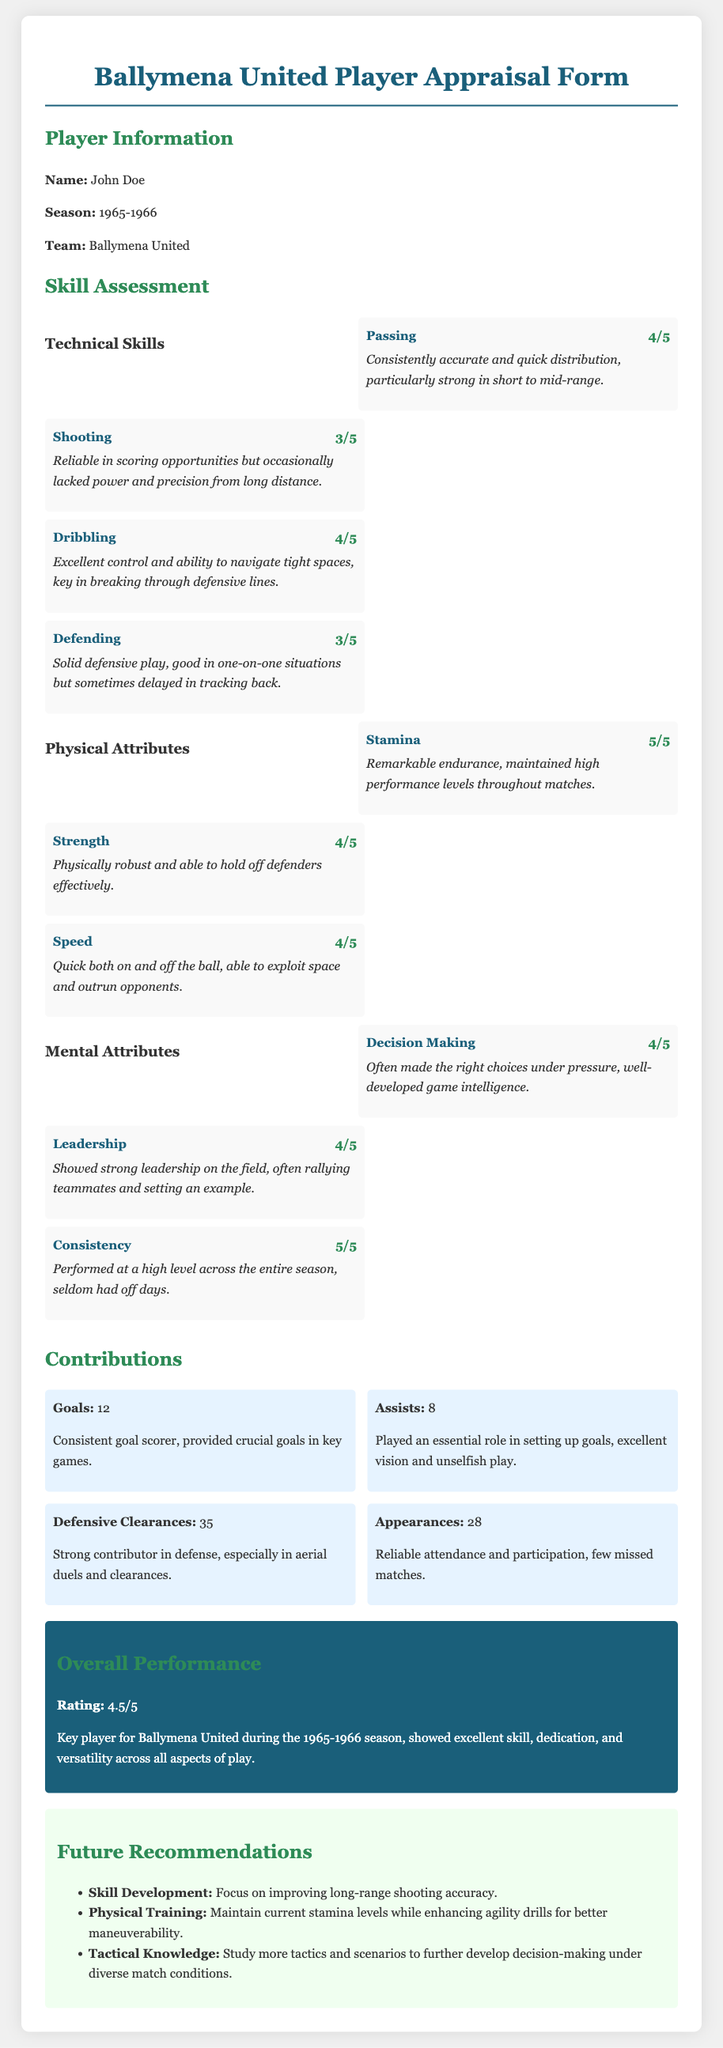What is the player's name? The player's name is stated in the Player Information section of the document.
Answer: John Doe What season is being reviewed? The season being reviewed is mentioned in the Player Information section.
Answer: 1965-1966 What is the rating for Stamina? The rating for Stamina is found in the Skill Assessment section under Physical Attributes.
Answer: 5/5 How many goals did the player score? The number of goals is provided in the Contributions section of the document.
Answer: 12 What skill received a rating of 3/5? The question looks for a skill with a specific rating in the Skill Assessment section.
Answer: Shooting What attribute received the highest rating overall? The question examines the Skill Assessment section for attributes with the highest ratings.
Answer: Consistency What is the overall performance rating? The overall performance rating is indicated in the Overall Performance section.
Answer: 4.5/5 What future recommendation focuses on shooting? The question asks about a specific recommendation listed in the Future Recommendations section.
Answer: Skill Development How many assists did the player have? The number of assists is listed under Contributions in the document.
Answer: 8 